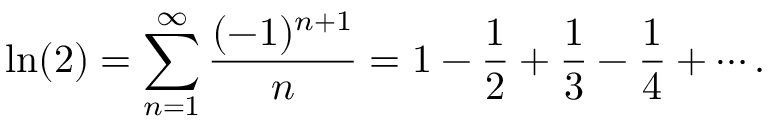Convert formula to latex. <formula><loc_0><loc_0><loc_500><loc_500>\ln ( 2 ) = \sum _ { n = 1 } ^ { \infty } { \frac { ( - 1 ) ^ { n + 1 } } { n } } = 1 - { \frac { 1 } { 2 } } + { \frac { 1 } { 3 } } - { \frac { 1 } { 4 } } + \cdots .</formula> 